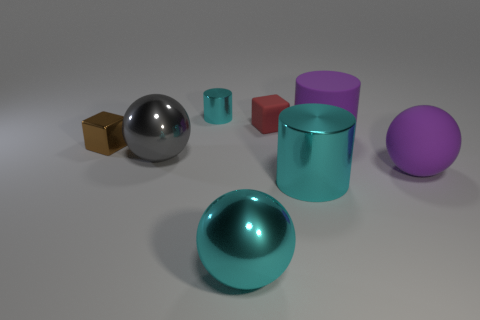There is a object that is both behind the gray object and on the right side of the small red cube; what is its size?
Ensure brevity in your answer.  Large. The tiny brown object has what shape?
Provide a short and direct response. Cube. How many big cyan metal things have the same shape as the tiny cyan thing?
Your response must be concise. 1. Is the number of purple objects that are to the left of the purple cylinder less than the number of large rubber cylinders behind the small brown thing?
Provide a succinct answer. Yes. How many big cylinders are left of the large matte cylinder that is in front of the rubber cube?
Provide a short and direct response. 1. Are any large cyan cylinders visible?
Offer a terse response. Yes. Is there a small cyan block that has the same material as the big gray thing?
Your response must be concise. No. Are there more metal cylinders that are to the left of the gray shiny object than tiny rubber blocks to the right of the big purple sphere?
Provide a short and direct response. No. Do the gray object and the purple matte cylinder have the same size?
Offer a very short reply. Yes. What color is the big object that is in front of the cyan cylinder in front of the tiny red thing?
Make the answer very short. Cyan. 